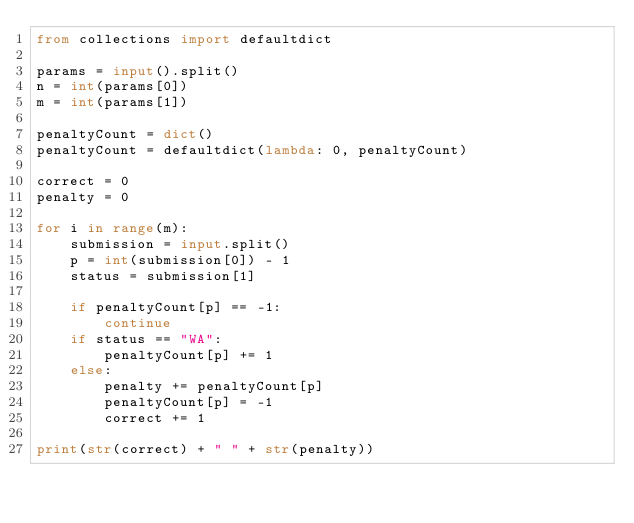Convert code to text. <code><loc_0><loc_0><loc_500><loc_500><_Python_>from collections import defaultdict

params = input().split()
n = int(params[0])
m = int(params[1])

penaltyCount = dict()
penaltyCount = defaultdict(lambda: 0, penaltyCount)

correct = 0
penalty = 0

for i in range(m):
    submission = input.split()
    p = int(submission[0]) - 1
    status = submission[1]

    if penaltyCount[p] == -1:
        continue
    if status == "WA":
        penaltyCount[p] += 1
    else:
        penalty += penaltyCount[p]
        penaltyCount[p] = -1
        correct += 1

print(str(correct) + " " + str(penalty))

</code> 